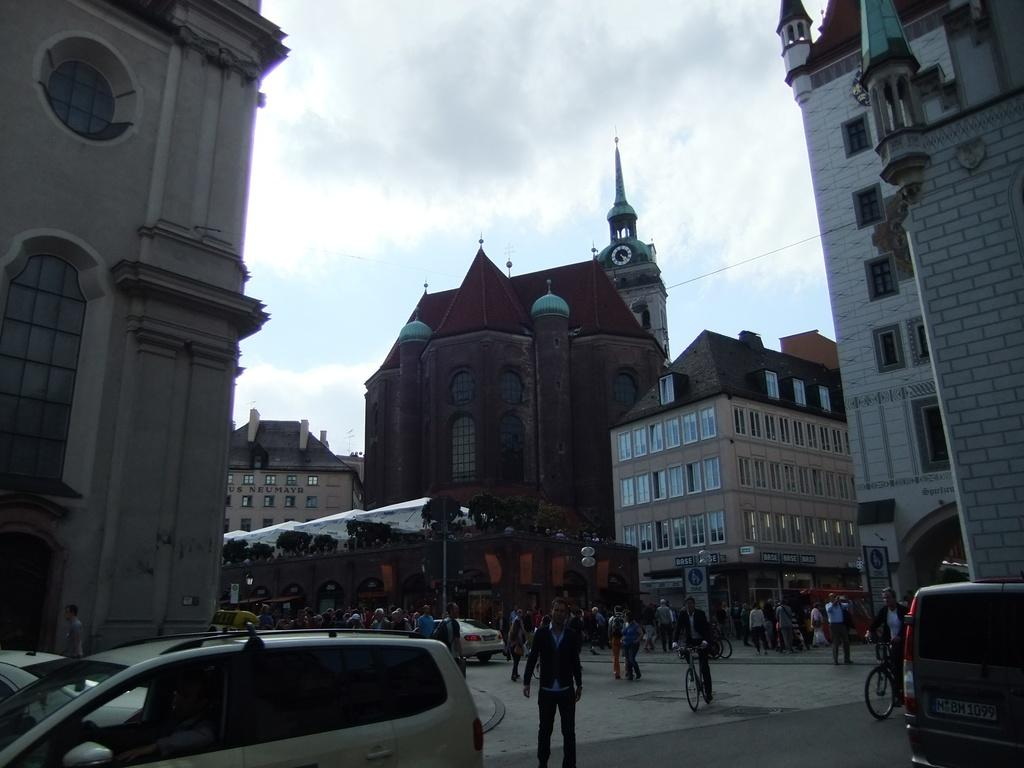What types of transportation can be seen on the road in the image? There are vehicles on the road in the image. What other mode of transportation can be seen in the image? There are people riding bicycles in the image. What can be seen in the background of the image? In the background, there is a tent, plants, and buildings. What is visible in the sky in the image? The sky is visible with clouds in the image. What territory is being claimed by the people riding bicycles in the image? There is no indication in the image that the people riding bicycles are claiming any territory. Which direction is north in the image? The image does not provide any information about the direction of north. 